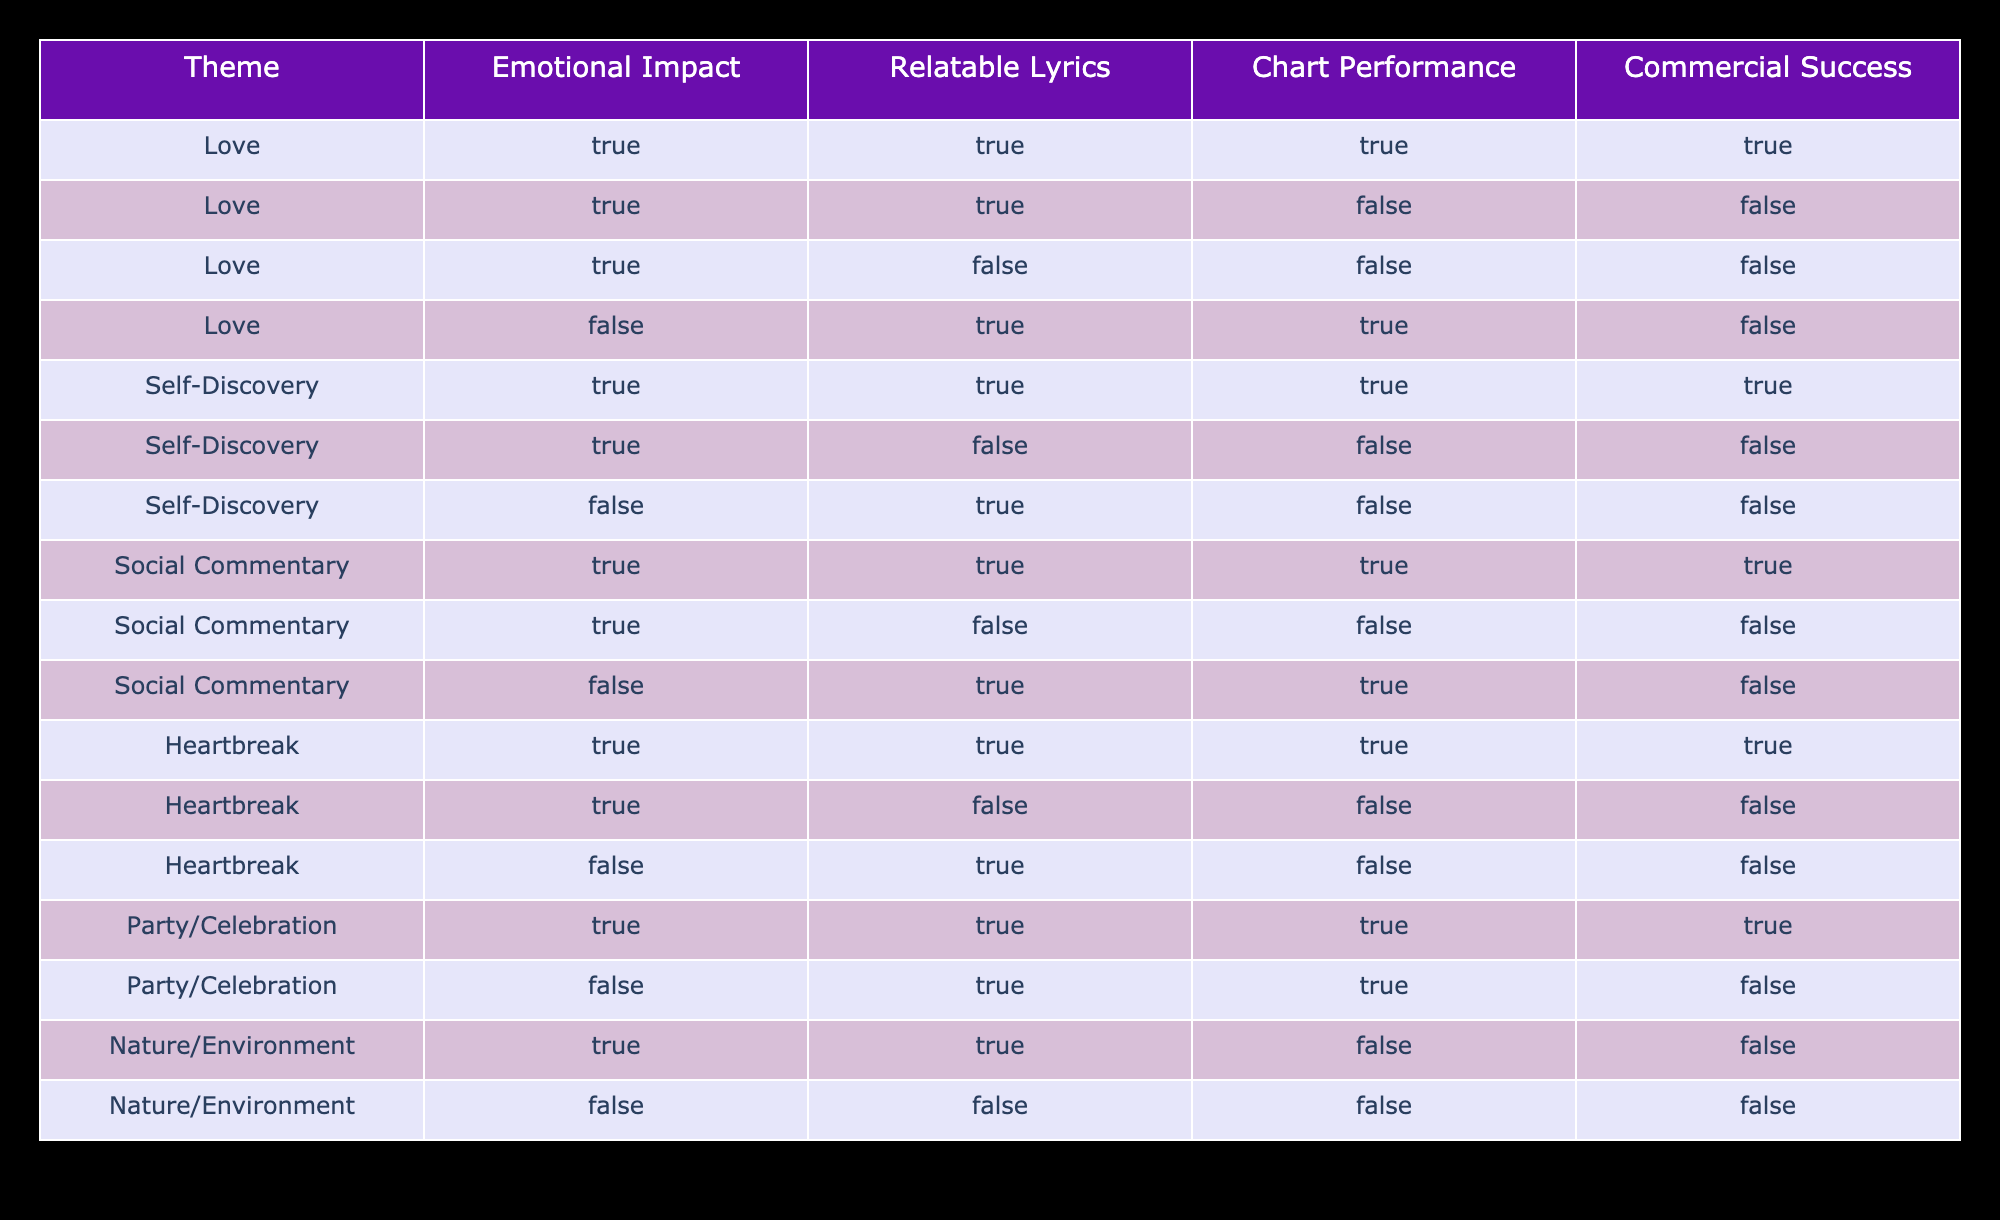What lyrical theme has the highest commercial success? By reviewing the table, the themes that have "True" in the Commercial Success column are Love, Self-Discovery, Social Commentary, Heartbreak, and Party/Celebration. Among these, Love appears the most frequently with "True" values, suggesting it has the highest commercial success.
Answer: Love How many themes show a combination of relatable lyrics and emotional impact leading to chart performance? The table shows that there are four themes (Love, Self-Discovery, Social Commentary, and Heartbreak) with true values for both Relatable Lyrics and Emotional Impact, and their Chart Performance is also true. Thus, there are four such themes.
Answer: 4 Is there a lyrical theme that has relatable lyrics but does not lead to commercial success? Examining the data, Party/Celebration shows "True" for Relatable Lyrics but has "False" for Commercial Success in one instance. Similarly, Nature/Environment has both "False" values in emotional impact and commercial success. Thus, yes, there are themes that fit this description.
Answer: Yes What is the total number of themes that achieve chart performance when emotional impact is true? From the table, if we look for the rows where Emotional Impact is true, the themes that also have True for Chart Performance are Love (2 times), Self-Discovery, Social Commentary, Heartbreak, and Party/Celebration, making it a total of five themes that meet this criterion.
Answer: 5 Which themes are characterized by emotional impact and have not achieved commercial success? Reviewing the table, the themes that have "True" for Emotional Impact and "False" for Commercial Success include Love (one instance), Self-Discovery, Social Commentary (one instance), and Nature/Environment, which totals four instances across different themes.
Answer: 4 How often does the theme of Nature/Environment show a true value for any type of commercial success? The theme of Nature/Environment only has "False" for Commercial Success in both entries, indicating it has never achieved commercial success. Therefore, it shows 0 instances of true value for commercial success.
Answer: 0 Are there any themes that have emotional impact but do not have relatable lyrics? By examining the table, the themes of Self-Discovery and Nature/Environment both have "True" for Emotional Impact but "False" for Relatable Lyrics. Therefore, there are two themes that match this condition.
Answer: 2 Which theme has the highest occurrence of fun or celebration-related lyrics according to the table? The theme Party/Celebration shows up twice, with one entry achieving both emotional impact and chart performance, leading to high presence and potential for celebration-related lyrics. Therefore, Party/Celebration is the theme most associated with fun.
Answer: Party/Celebration 